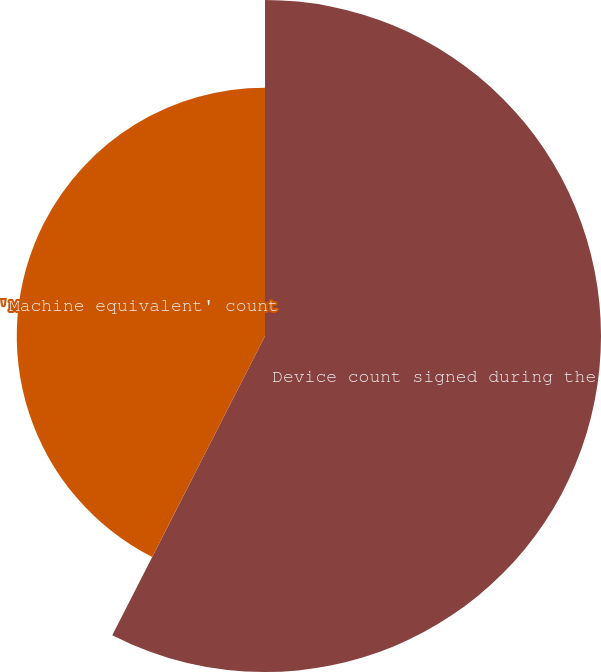<chart> <loc_0><loc_0><loc_500><loc_500><pie_chart><fcel>Device count signed during the<fcel>'Machine equivalent' count<nl><fcel>57.51%<fcel>42.49%<nl></chart> 